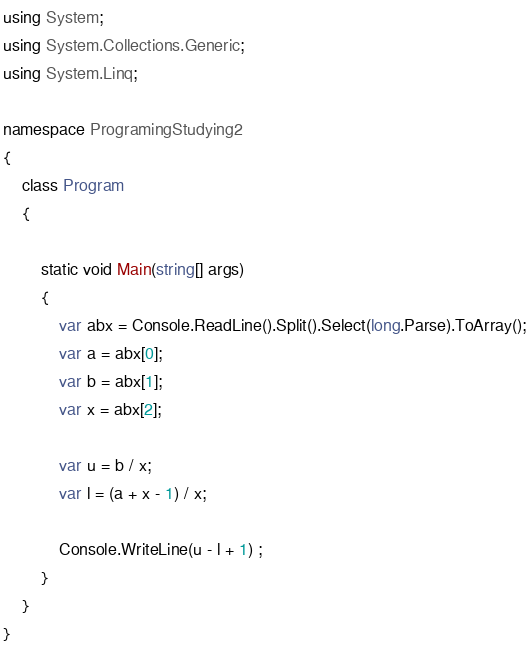<code> <loc_0><loc_0><loc_500><loc_500><_C#_>using System;
using System.Collections.Generic;
using System.Linq;

namespace ProgramingStudying2
{
    class Program
    {

        static void Main(string[] args)
        {
            var abx = Console.ReadLine().Split().Select(long.Parse).ToArray();
            var a = abx[0];
            var b = abx[1];
            var x = abx[2];

            var u = b / x;
            var l = (a + x - 1) / x;

            Console.WriteLine(u - l + 1) ;
        }
    }
}
</code> 